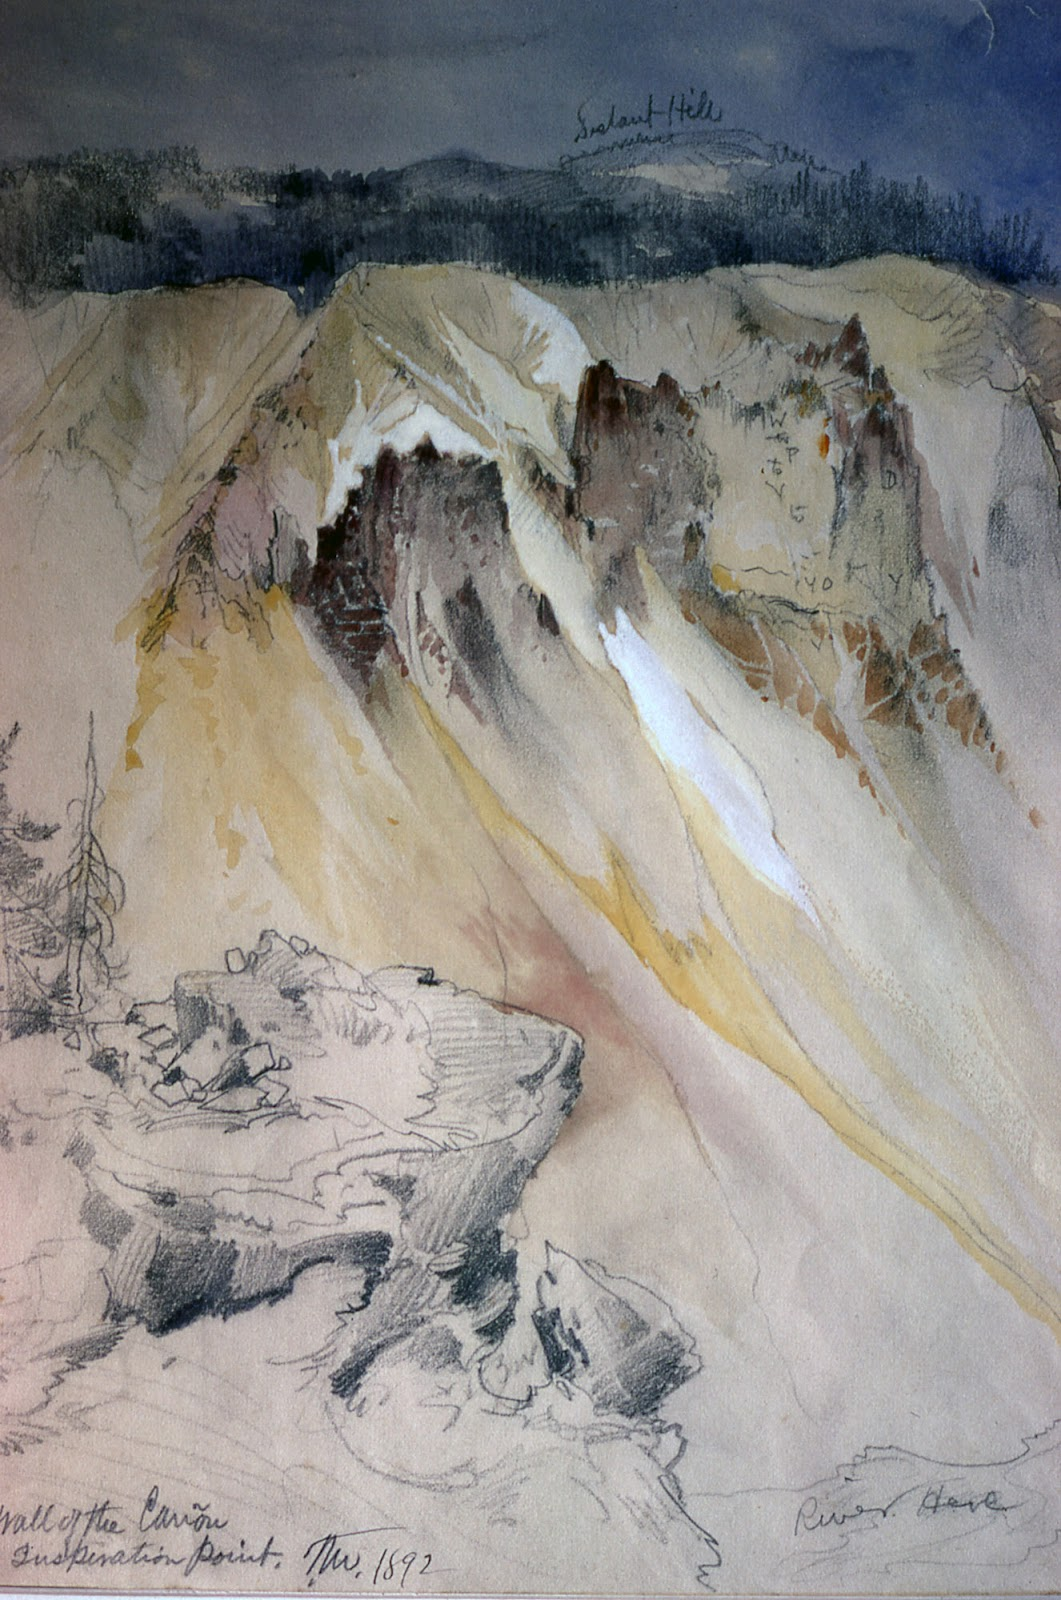What can you tell me about the techniques used in this painting? The painting employs a combination of watercolor and graphite, which John Ruskin was known to use. Watercolor is used to create the soft tints and delicate gradations, bringing a gentle and ethereal quality to the scene. Graphite adds detail and texture, enhancing the rugged features of the landscape. The blending of these mediums allows for both broad washes of color and precise lines, giving a sense of both spontaneity and meticulous observation. The use of loose, sketchy strokes is a hallmark of Ruskin’s work, offering a vibrant yet realistic representation of nature. Could this painting be depicting a specific location? Yes, the painting likely depicts a specific location, as indicated by the inscriptions 'Sulahnd Hills' and 'Valley of the Canyon'. These names could correspond to real places, potentially in the mountainous regions that Ruskin explored. Given the date and Ruskin's interest in faithfully capturing nature, it's plausible he painted this scene during his travels to study geology and landscapes. The title 'Valley of the Canyon,' hints at a significant and recognizable geographic feature, which may have been a popular subject for his era. 